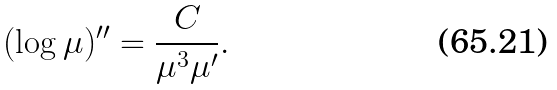<formula> <loc_0><loc_0><loc_500><loc_500>( \log \mu ) ^ { \prime \prime } = \frac { C } { \mu ^ { 3 } \mu ^ { \prime } } .</formula> 